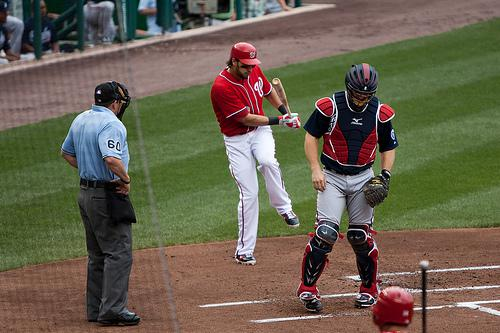Question: how many men are shown on the field?
Choices:
A. Five.
B. Two.
C. Three.
D. Four.
Answer with the letter. Answer: D Question: who is the man in the light blue shirt?
Choices:
A. Batter.
B. The umpire.
C. Pitcher.
D. A spectator.
Answer with the letter. Answer: B Question: what are the men standing on?
Choices:
A. In the stand.
B. In a car park.
C. A baseball diamond.
D. In the press box.
Answer with the letter. Answer: C Question: who is standing in front of the umpire?
Choices:
A. The batter.
B. A crowd.
C. The team.
D. The catcher.
Answer with the letter. Answer: D Question: what is on the ground?
Choices:
A. Rocks.
B. Water.
C. Clay and grass.
D. Dirt.
Answer with the letter. Answer: C Question: what game is being played?
Choices:
A. Baseball.
B. Basketball.
C. Soccer.
D. Tennis.
Answer with the letter. Answer: A Question: who is holding a baseball bat?
Choices:
A. The team captain.
B. A parent.
C. A child wearing gloves.
D. The player in the red jersey.
Answer with the letter. Answer: D 